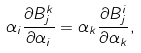Convert formula to latex. <formula><loc_0><loc_0><loc_500><loc_500>\alpha _ { i } \frac { \partial B ^ { k } _ { j } } { \partial \alpha _ { i } } = \alpha _ { k } \frac { \partial B ^ { i } _ { j } } { \partial \alpha _ { k } } ,</formula> 